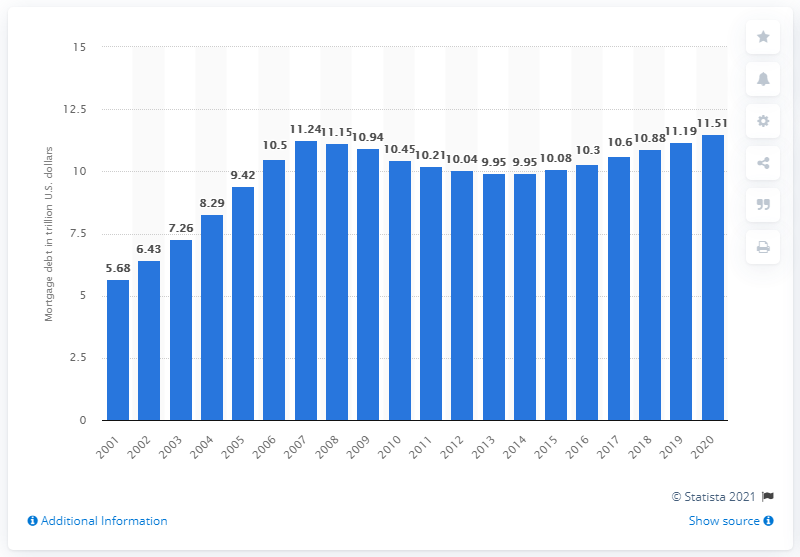Identify some key points in this picture. In the third quarter of 2020, the total outstanding mortgage debt on one-to-four-family residences in the United States was $11.51 billion. 